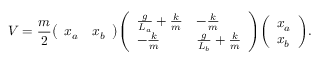Convert formula to latex. <formula><loc_0><loc_0><loc_500><loc_500>V = { \frac { m } { 2 } } { \left ( \begin{array} { l l } { x _ { a } } & { x _ { b } } \end{array} \right ) } { \left ( \begin{array} { l l } { { \frac { g } { L _ { a } } } + { \frac { k } { m } } } & { - { \frac { k } { m } } } \\ { - { \frac { k } { m } } } & { { \frac { g } { L _ { b } } } + { \frac { k } { m } } } \end{array} \right ) } { \left ( \begin{array} { l } { x _ { a } } \\ { x _ { b } } \end{array} \right ) } .</formula> 